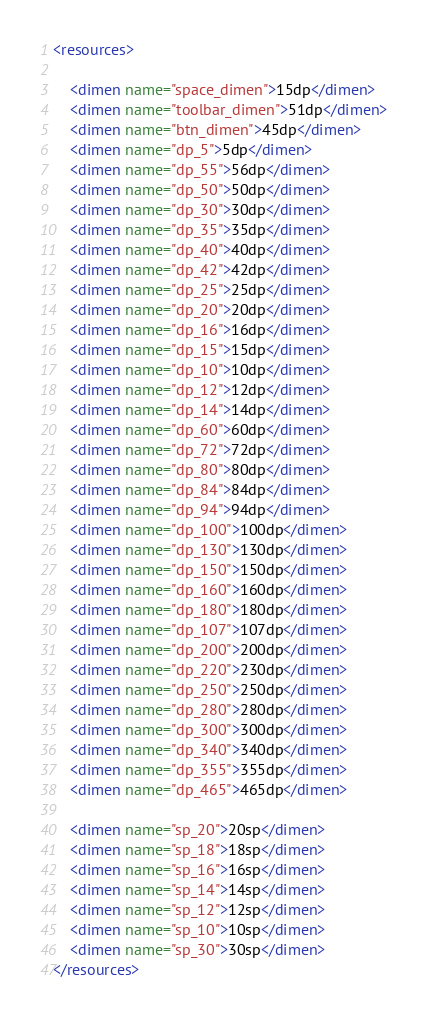Convert code to text. <code><loc_0><loc_0><loc_500><loc_500><_XML_><resources>

    <dimen name="space_dimen">15dp</dimen>
    <dimen name="toolbar_dimen">51dp</dimen>
    <dimen name="btn_dimen">45dp</dimen>
    <dimen name="dp_5">5dp</dimen>
    <dimen name="dp_55">56dp</dimen>
    <dimen name="dp_50">50dp</dimen>
    <dimen name="dp_30">30dp</dimen>
    <dimen name="dp_35">35dp</dimen>
    <dimen name="dp_40">40dp</dimen>
    <dimen name="dp_42">42dp</dimen>
    <dimen name="dp_25">25dp</dimen>
    <dimen name="dp_20">20dp</dimen>
    <dimen name="dp_16">16dp</dimen>
    <dimen name="dp_15">15dp</dimen>
    <dimen name="dp_10">10dp</dimen>
    <dimen name="dp_12">12dp</dimen>
    <dimen name="dp_14">14dp</dimen>
    <dimen name="dp_60">60dp</dimen>
    <dimen name="dp_72">72dp</dimen>
    <dimen name="dp_80">80dp</dimen>
    <dimen name="dp_84">84dp</dimen>
    <dimen name="dp_94">94dp</dimen>
    <dimen name="dp_100">100dp</dimen>
    <dimen name="dp_130">130dp</dimen>
    <dimen name="dp_150">150dp</dimen>
    <dimen name="dp_160">160dp</dimen>
    <dimen name="dp_180">180dp</dimen>
    <dimen name="dp_107">107dp</dimen>
    <dimen name="dp_200">200dp</dimen>
    <dimen name="dp_220">230dp</dimen>
    <dimen name="dp_250">250dp</dimen>
    <dimen name="dp_280">280dp</dimen>
    <dimen name="dp_300">300dp</dimen>
    <dimen name="dp_340">340dp</dimen>
    <dimen name="dp_355">355dp</dimen>
    <dimen name="dp_465">465dp</dimen>

    <dimen name="sp_20">20sp</dimen>
    <dimen name="sp_18">18sp</dimen>
    <dimen name="sp_16">16sp</dimen>
    <dimen name="sp_14">14sp</dimen>
    <dimen name="sp_12">12sp</dimen>
    <dimen name="sp_10">10sp</dimen>
    <dimen name="sp_30">30sp</dimen>
</resources>
</code> 